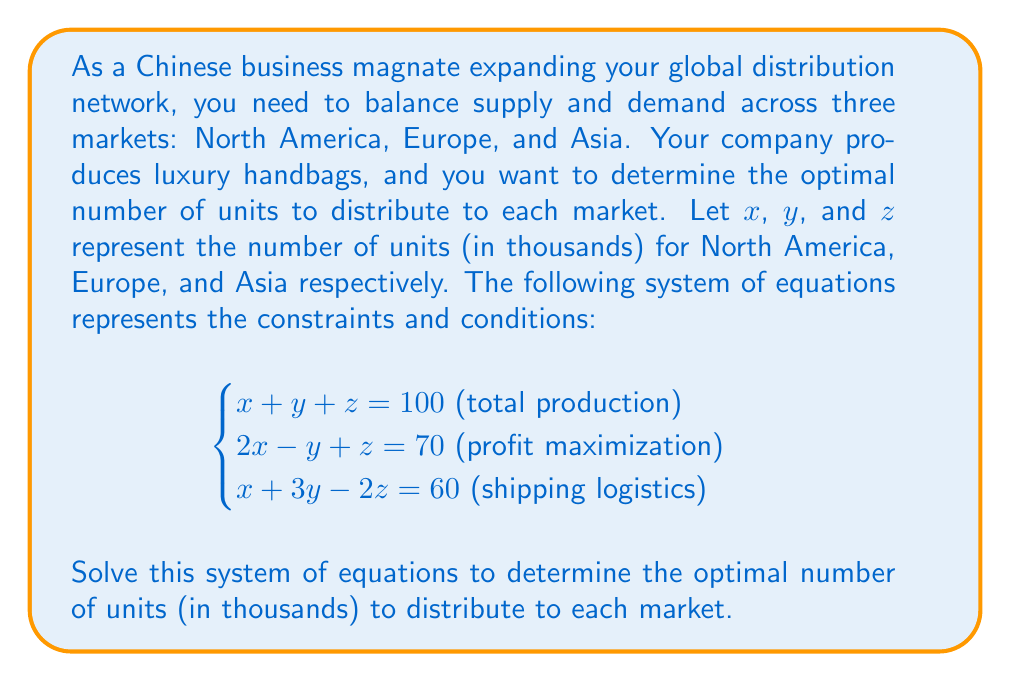Could you help me with this problem? To solve this system of equations, we'll use the elimination method:

1) First, let's eliminate $z$ by adding equations (1) and (2):
   $$(x + y + z) + (2x - y + z) = 100 + 70$$
   $$3x = 170$$
   $$x = \frac{170}{3}$$

2) Now, let's substitute this value of $x$ into equation (1):
   $$\frac{170}{3} + y + z = 100$$
   $$y + z = 100 - \frac{170}{3} = \frac{130}{3}$$

3) Next, let's substitute the values we know into equation (3):
   $$\frac{170}{3} + 3y - 2z = 60$$
   $$3y - 2z = 60 - \frac{170}{3} = \frac{10}{3}$$

4) Now we have two equations with two unknowns:
   $$\begin{cases}
   y + z = \frac{130}{3}\\
   3y - 2z = \frac{10}{3}
   \end{cases}$$

5) Multiply the first equation by 3 and the second by 1:
   $$\begin{cases}
   3y + 3z = 130\\
   3y - 2z = \frac{10}{3}
   \end{cases}$$

6) Subtract the second equation from the first:
   $$5z = 130 - \frac{10}{3} = \frac{380}{3}$$
   $$z = \frac{76}{3}$$

7) Substitute this value of $z$ back into $y + z = \frac{130}{3}$:
   $$y + \frac{76}{3} = \frac{130}{3}$$
   $$y = \frac{130}{3} - \frac{76}{3} = \frac{54}{3} = 18$$

8) We can now calculate $x$:
   $$x = \frac{170}{3}$$

Therefore, the solution is:
$x = \frac{170}{3}$, $y = 18$, and $z = \frac{76}{3}$
Answer: The optimal distribution (in thousands of units) is:
North America ($x$): $\frac{170}{3} \approx 56.67$
Europe ($y$): $18$
Asia ($z$): $\frac{76}{3} \approx 25.33$ 